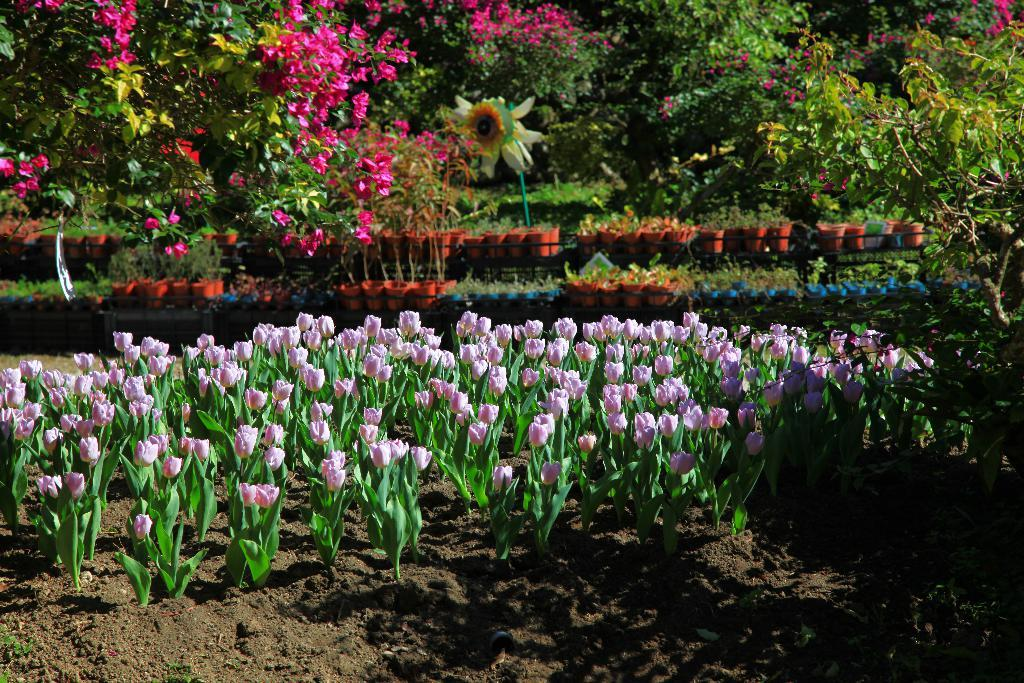What types of vegetation can be seen in the image? Flowers, plants, and trees can be seen in the image. What objects are present to hold the flowers and plants? Flower pots are present in the image. Can you describe the natural setting visible in the image? The natural setting includes flowers, plants, and trees. What type of disgusting smell can be detected in the image? There is no indication of any smell, good or bad, in the image. Can you hear a bell ringing in the image? There is no bell present in the image, so it is not possible to hear it ringing. 